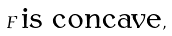<formula> <loc_0><loc_0><loc_500><loc_500>F \, \text {is concave} ,</formula> 